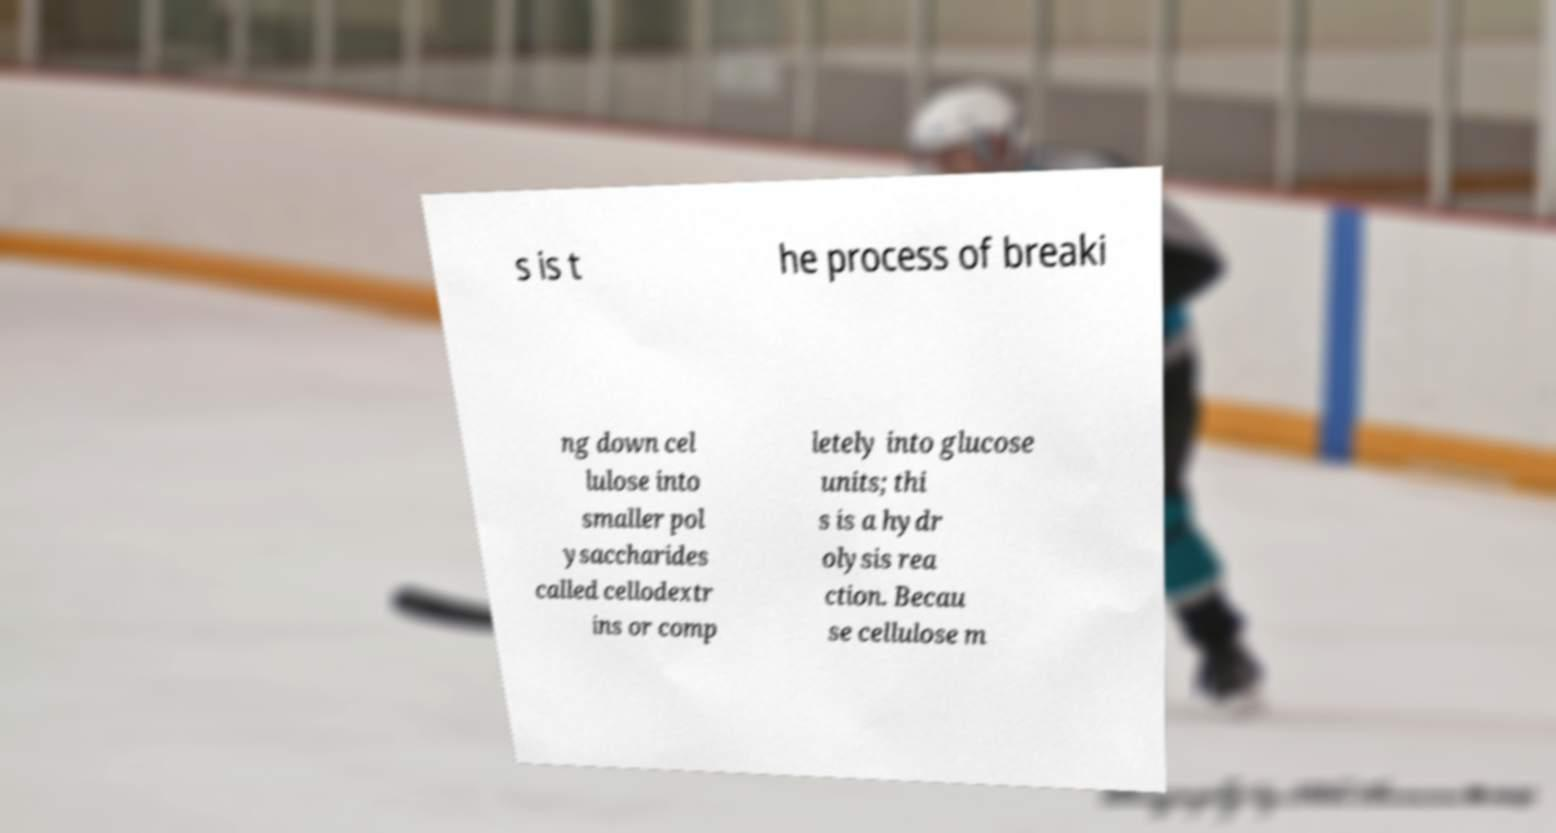There's text embedded in this image that I need extracted. Can you transcribe it verbatim? s is t he process of breaki ng down cel lulose into smaller pol ysaccharides called cellodextr ins or comp letely into glucose units; thi s is a hydr olysis rea ction. Becau se cellulose m 